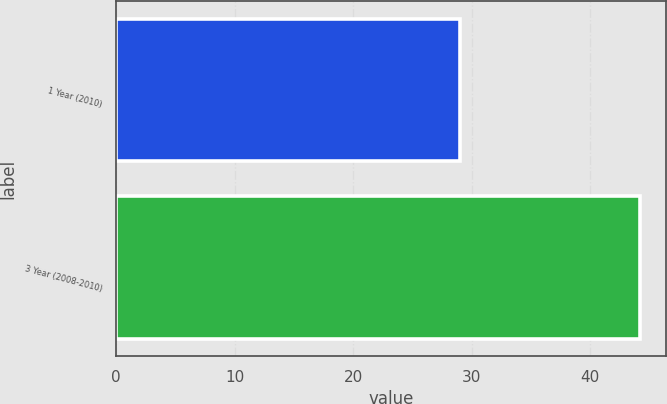<chart> <loc_0><loc_0><loc_500><loc_500><bar_chart><fcel>1 Year (2010)<fcel>3 Year (2008-2010)<nl><fcel>29<fcel>44.2<nl></chart> 